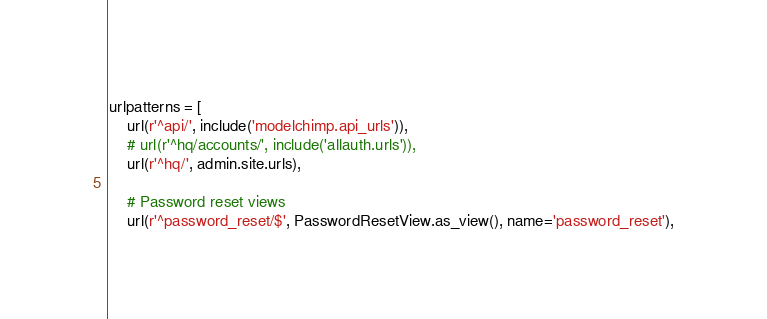<code> <loc_0><loc_0><loc_500><loc_500><_Python_>urlpatterns = [
    url(r'^api/', include('modelchimp.api_urls')),
    # url(r'^hq/accounts/', include('allauth.urls')),
    url(r'^hq/', admin.site.urls),

    # Password reset views
    url(r'^password_reset/$', PasswordResetView.as_view(), name='password_reset'),</code> 